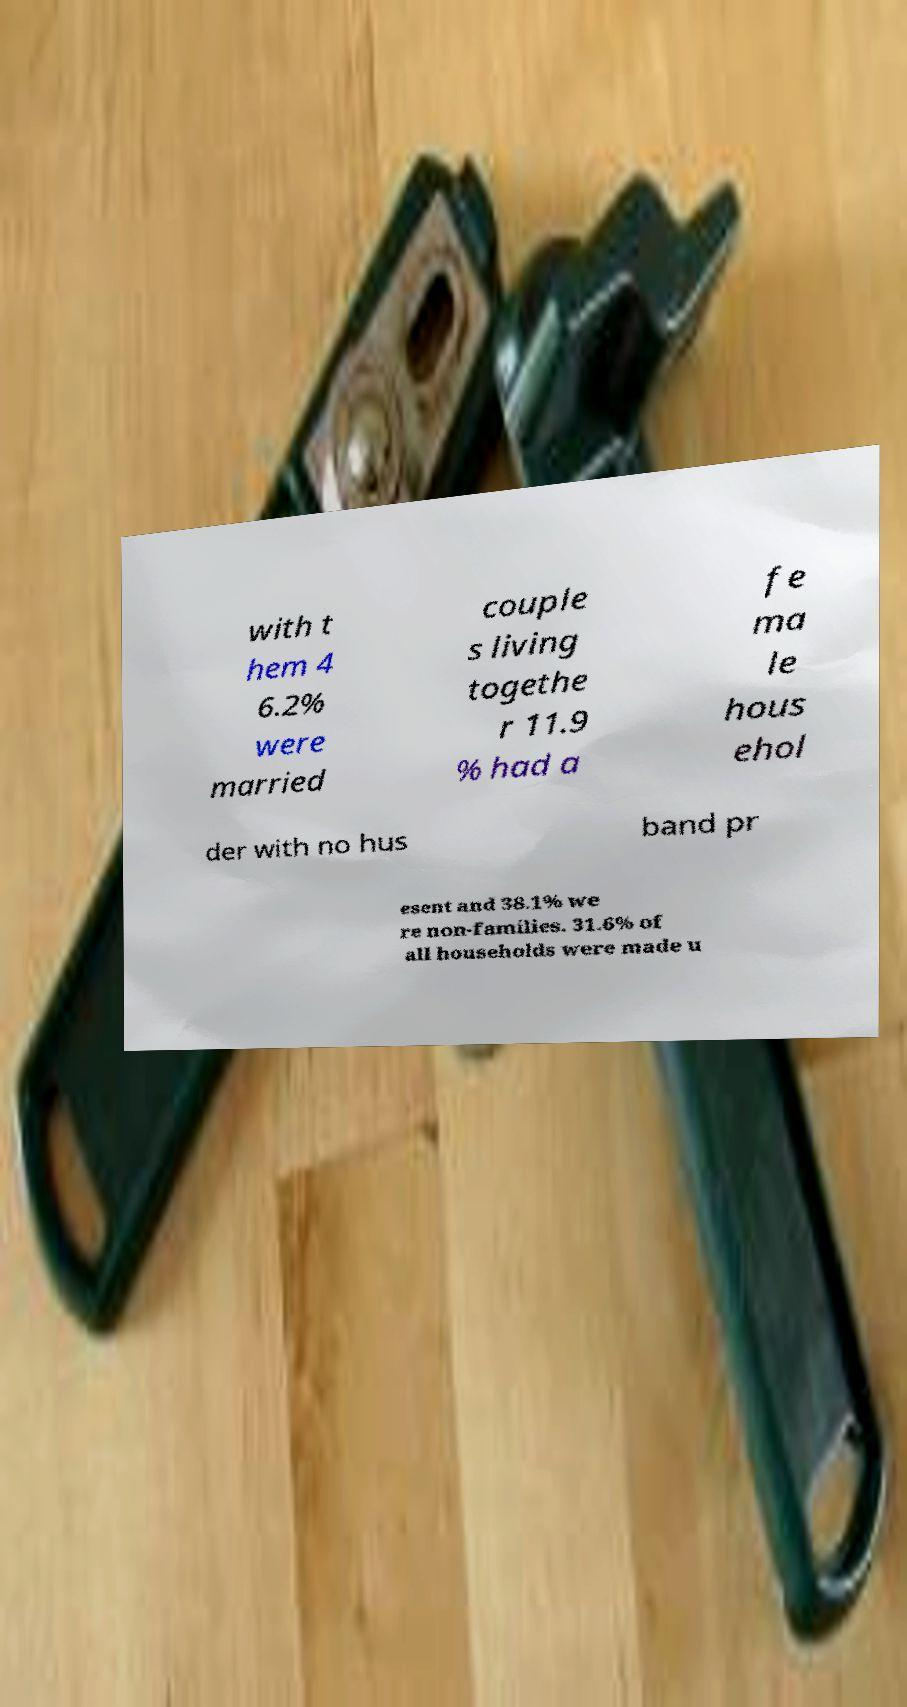Can you read and provide the text displayed in the image?This photo seems to have some interesting text. Can you extract and type it out for me? with t hem 4 6.2% were married couple s living togethe r 11.9 % had a fe ma le hous ehol der with no hus band pr esent and 38.1% we re non-families. 31.6% of all households were made u 